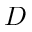<formula> <loc_0><loc_0><loc_500><loc_500>D</formula> 